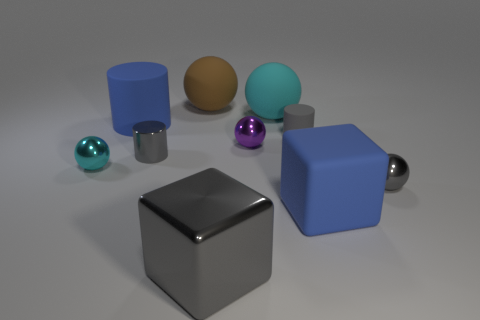Subtract all big rubber balls. How many balls are left? 3 Subtract 1 balls. How many balls are left? 4 Subtract all blue cylinders. How many cyan spheres are left? 2 Subtract all purple balls. How many balls are left? 4 Subtract all green cylinders. Subtract all brown spheres. How many cylinders are left? 3 Subtract all cylinders. How many objects are left? 7 Subtract all large blue rubber things. Subtract all blue things. How many objects are left? 6 Add 5 tiny cyan metallic spheres. How many tiny cyan metallic spheres are left? 6 Add 3 big cyan objects. How many big cyan objects exist? 4 Subtract 0 yellow blocks. How many objects are left? 10 